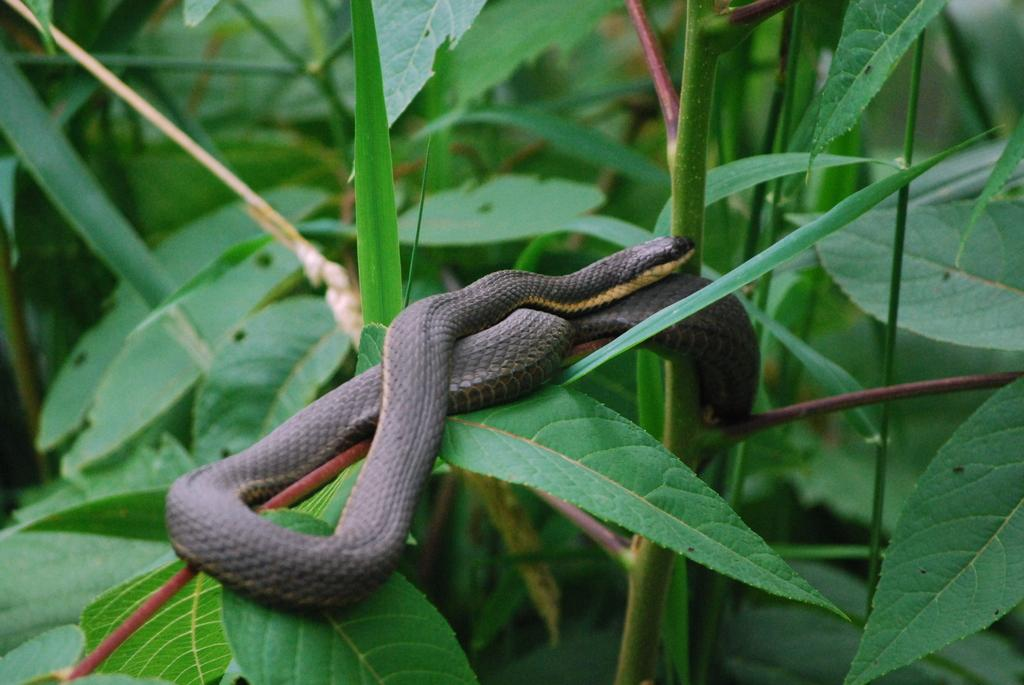What is the main subject in the foreground of the image? There is a black snake in the foreground of the image. What is the snake resting on? The snake is on a plant. What can be seen in the background of the image? There are plants visible in the background of the image. Can you see a rose being kissed by the snake in the image? There is no rose or kissing action depicted in the image; it features a black snake on a plant. 